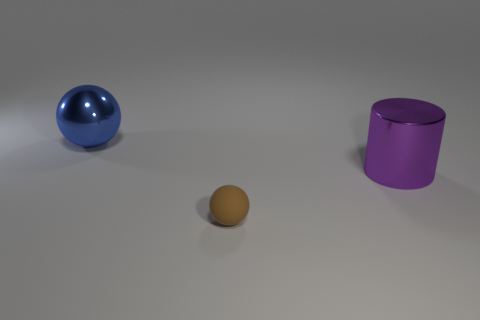Are there any things that have the same material as the blue sphere?
Ensure brevity in your answer.  Yes. Do the large ball and the thing in front of the big purple thing have the same material?
Give a very brief answer. No. There is another metallic object that is the same size as the blue thing; what is its color?
Keep it short and to the point. Purple. What size is the metal object that is to the left of the thing that is in front of the purple metallic cylinder?
Keep it short and to the point. Large. Does the tiny rubber sphere have the same color as the large shiny thing that is behind the purple cylinder?
Your response must be concise. No. Are there fewer rubber spheres that are to the left of the purple shiny object than large yellow cubes?
Offer a terse response. No. How many other objects are the same size as the brown matte sphere?
Keep it short and to the point. 0. Is the shape of the large thing on the right side of the big blue shiny sphere the same as  the big blue object?
Offer a terse response. No. Is the number of big purple shiny things that are to the left of the cylinder greater than the number of big spheres?
Your answer should be compact. No. What is the object that is both behind the matte sphere and on the right side of the large blue ball made of?
Ensure brevity in your answer.  Metal. 